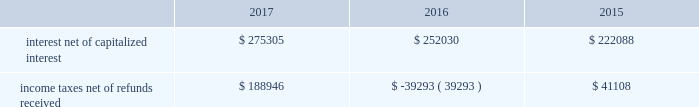The diluted earnings per share calculation excludes stock options , sars , restricted stock and units and performance units and stock that were anti-dilutive .
Shares underlying the excluded stock options and sars totaled 2.6 million , 10.3 million and 10.2 million for the years ended december 31 , 2017 , 2016 and 2015 , respectively .
For the year ended december 31 , 2016 , 4.5 million shares of restricted stock and restricted stock units and performance units and performance stock were excluded .
10 .
Supplemental cash flow information net cash paid for interest and income taxes was as follows for the years ended december 31 , 2017 , 2016 and 2015 ( in thousands ) : .
Eog's accrued capital expenditures at december 31 , 2017 , 2016 and 2015 were $ 475 million , $ 388 million and $ 416 million , respectively .
Non-cash investing activities for the year ended december 31 , 2017 included non-cash additions of $ 282 million to eog's oil and gas properties as a result of property exchanges .
Non-cash investing activities for the year ended december 31 , 2016 included $ 3834 million in non-cash additions to eog's oil and gas properties related to the yates transaction ( see note 17 ) .
11 .
Business segment information eog's operations are all crude oil and natural gas exploration and production related .
The segment reporting topic of the asc establishes standards for reporting information about operating segments in annual financial statements .
Operating segments are defined as components of an enterprise about which separate financial information is available and evaluated regularly by the chief operating decision maker , or decision-making group , in deciding how to allocate resources and in assessing performance .
Eog's chief operating decision-making process is informal and involves the chairman of the board and chief executive officer and other key officers .
This group routinely reviews and makes operating decisions related to significant issues associated with each of eog's major producing areas in the united states , trinidad , the united kingdom and china .
For segment reporting purposes , the chief operating decision maker considers the major united states producing areas to be one operating segment. .
What is the increase observed in the interest net of capitalized interest during 2016 and 2017? 
Rationale: it is the cash paid as interest net of capitalized interest in 2017 divided by the 2016's , then turned into a percentage to represent the increase .
Computations: ((275305 / 252030) - 1)
Answer: 0.09235. 